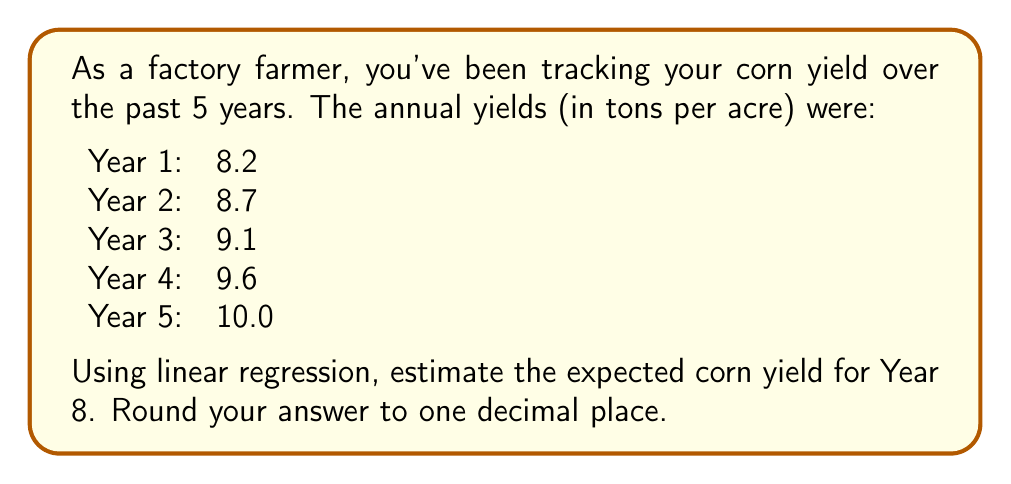Teach me how to tackle this problem. To solve this problem, we'll use linear regression to find the line of best fit and then use it to predict the yield for Year 8.

1. Let's define our variables:
   $x$: years (1, 2, 3, 4, 5)
   $y$: yield (8.2, 8.7, 9.1, 9.6, 10.0)

2. We need to calculate the following:
   $n = 5$ (number of data points)
   $\sum x = 1 + 2 + 3 + 4 + 5 = 15$
   $\sum y = 8.2 + 8.7 + 9.1 + 9.6 + 10.0 = 45.6$
   $\sum xy = (1)(8.2) + (2)(8.7) + (3)(9.1) + (4)(9.6) + (5)(10.0) = 146.6$
   $\sum x^2 = 1^2 + 2^2 + 3^2 + 4^2 + 5^2 = 55$

3. Use the linear regression formula to find the slope (m) and y-intercept (b):

   $$m = \frac{n\sum xy - \sum x \sum y}{n\sum x^2 - (\sum x)^2}$$
   
   $$m = \frac{5(146.6) - 15(45.6)}{5(55) - 15^2} = \frac{733 - 684}{275 - 225} = \frac{49}{50} = 0.98$$

   $$b = \frac{\sum y - m\sum x}{n}$$
   
   $$b = \frac{45.6 - 0.98(15)}{5} = \frac{45.6 - 14.7}{5} = \frac{30.9}{5} = 6.18$$

4. The line of best fit is:
   $$y = 0.98x + 6.18$$

5. To estimate the yield for Year 8, substitute x = 8:
   $$y = 0.98(8) + 6.18 = 7.84 + 6.18 = 14.02$$

6. Rounding to one decimal place: 14.0
Answer: 14.0 tons per acre 